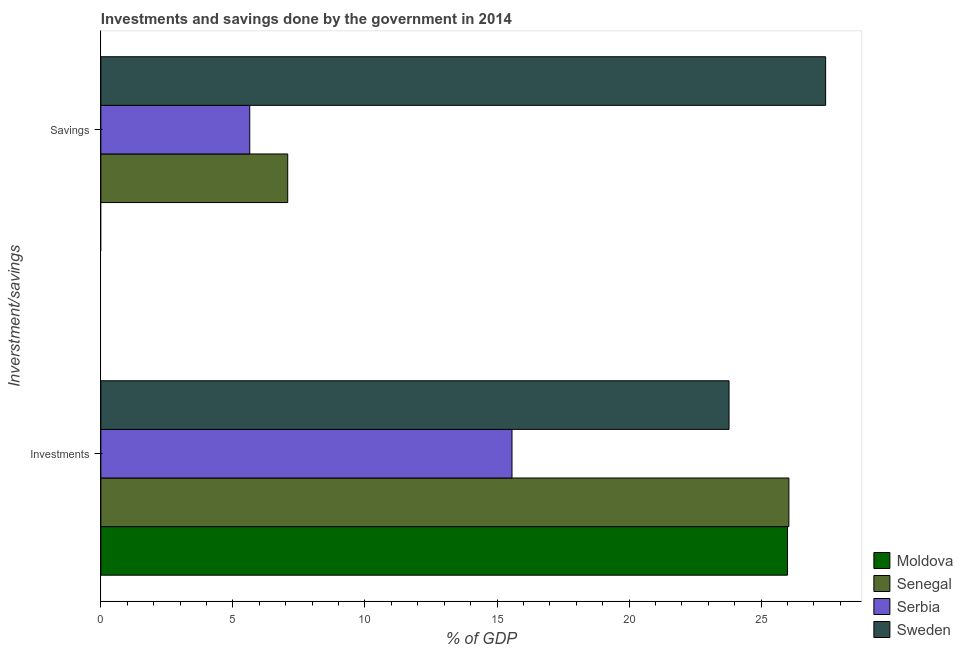How many different coloured bars are there?
Your answer should be very brief. 4. Are the number of bars on each tick of the Y-axis equal?
Keep it short and to the point. No. How many bars are there on the 1st tick from the bottom?
Give a very brief answer. 4. What is the label of the 1st group of bars from the top?
Your answer should be compact. Savings. What is the investments of government in Serbia?
Provide a short and direct response. 15.57. Across all countries, what is the maximum savings of government?
Your answer should be very brief. 27.44. Across all countries, what is the minimum investments of government?
Provide a succinct answer. 15.57. In which country was the savings of government maximum?
Provide a succinct answer. Sweden. What is the total investments of government in the graph?
Provide a short and direct response. 91.4. What is the difference between the investments of government in Serbia and that in Moldova?
Ensure brevity in your answer.  -10.43. What is the difference between the investments of government in Sweden and the savings of government in Senegal?
Your answer should be very brief. 16.71. What is the average investments of government per country?
Your response must be concise. 22.85. What is the difference between the investments of government and savings of government in Serbia?
Provide a succinct answer. 9.93. In how many countries, is the investments of government greater than 26 %?
Offer a terse response. 1. What is the ratio of the investments of government in Moldova to that in Serbia?
Provide a short and direct response. 1.67. Are all the bars in the graph horizontal?
Your response must be concise. Yes. How many countries are there in the graph?
Ensure brevity in your answer.  4. Are the values on the major ticks of X-axis written in scientific E-notation?
Provide a short and direct response. No. Where does the legend appear in the graph?
Provide a short and direct response. Bottom right. How are the legend labels stacked?
Make the answer very short. Vertical. What is the title of the graph?
Provide a succinct answer. Investments and savings done by the government in 2014. What is the label or title of the X-axis?
Offer a very short reply. % of GDP. What is the label or title of the Y-axis?
Your answer should be compact. Inverstment/savings. What is the % of GDP of Moldova in Investments?
Provide a short and direct response. 26. What is the % of GDP of Senegal in Investments?
Keep it short and to the point. 26.05. What is the % of GDP of Serbia in Investments?
Provide a succinct answer. 15.57. What is the % of GDP in Sweden in Investments?
Make the answer very short. 23.78. What is the % of GDP in Moldova in Savings?
Your answer should be compact. 0. What is the % of GDP of Senegal in Savings?
Keep it short and to the point. 7.08. What is the % of GDP in Serbia in Savings?
Ensure brevity in your answer.  5.64. What is the % of GDP of Sweden in Savings?
Provide a succinct answer. 27.44. Across all Inverstment/savings, what is the maximum % of GDP in Moldova?
Provide a succinct answer. 26. Across all Inverstment/savings, what is the maximum % of GDP in Senegal?
Keep it short and to the point. 26.05. Across all Inverstment/savings, what is the maximum % of GDP of Serbia?
Provide a succinct answer. 15.57. Across all Inverstment/savings, what is the maximum % of GDP in Sweden?
Provide a succinct answer. 27.44. Across all Inverstment/savings, what is the minimum % of GDP in Senegal?
Offer a very short reply. 7.08. Across all Inverstment/savings, what is the minimum % of GDP of Serbia?
Make the answer very short. 5.64. Across all Inverstment/savings, what is the minimum % of GDP of Sweden?
Your answer should be compact. 23.78. What is the total % of GDP of Moldova in the graph?
Keep it short and to the point. 26. What is the total % of GDP in Senegal in the graph?
Ensure brevity in your answer.  33.12. What is the total % of GDP of Serbia in the graph?
Provide a short and direct response. 21.2. What is the total % of GDP in Sweden in the graph?
Give a very brief answer. 51.23. What is the difference between the % of GDP of Senegal in Investments and that in Savings?
Keep it short and to the point. 18.97. What is the difference between the % of GDP of Serbia in Investments and that in Savings?
Your answer should be compact. 9.93. What is the difference between the % of GDP in Sweden in Investments and that in Savings?
Make the answer very short. -3.66. What is the difference between the % of GDP of Moldova in Investments and the % of GDP of Senegal in Savings?
Make the answer very short. 18.92. What is the difference between the % of GDP of Moldova in Investments and the % of GDP of Serbia in Savings?
Ensure brevity in your answer.  20.36. What is the difference between the % of GDP in Moldova in Investments and the % of GDP in Sweden in Savings?
Your response must be concise. -1.44. What is the difference between the % of GDP of Senegal in Investments and the % of GDP of Serbia in Savings?
Provide a short and direct response. 20.41. What is the difference between the % of GDP in Senegal in Investments and the % of GDP in Sweden in Savings?
Give a very brief answer. -1.39. What is the difference between the % of GDP of Serbia in Investments and the % of GDP of Sweden in Savings?
Your answer should be very brief. -11.87. What is the average % of GDP of Moldova per Inverstment/savings?
Keep it short and to the point. 13. What is the average % of GDP of Senegal per Inverstment/savings?
Offer a terse response. 16.56. What is the average % of GDP in Serbia per Inverstment/savings?
Keep it short and to the point. 10.6. What is the average % of GDP in Sweden per Inverstment/savings?
Provide a short and direct response. 25.61. What is the difference between the % of GDP in Moldova and % of GDP in Senegal in Investments?
Offer a very short reply. -0.05. What is the difference between the % of GDP of Moldova and % of GDP of Serbia in Investments?
Offer a very short reply. 10.43. What is the difference between the % of GDP in Moldova and % of GDP in Sweden in Investments?
Ensure brevity in your answer.  2.21. What is the difference between the % of GDP in Senegal and % of GDP in Serbia in Investments?
Keep it short and to the point. 10.48. What is the difference between the % of GDP in Senegal and % of GDP in Sweden in Investments?
Offer a terse response. 2.27. What is the difference between the % of GDP of Serbia and % of GDP of Sweden in Investments?
Keep it short and to the point. -8.22. What is the difference between the % of GDP in Senegal and % of GDP in Serbia in Savings?
Offer a very short reply. 1.44. What is the difference between the % of GDP of Senegal and % of GDP of Sweden in Savings?
Make the answer very short. -20.37. What is the difference between the % of GDP in Serbia and % of GDP in Sweden in Savings?
Make the answer very short. -21.8. What is the ratio of the % of GDP of Senegal in Investments to that in Savings?
Your response must be concise. 3.68. What is the ratio of the % of GDP of Serbia in Investments to that in Savings?
Give a very brief answer. 2.76. What is the ratio of the % of GDP of Sweden in Investments to that in Savings?
Make the answer very short. 0.87. What is the difference between the highest and the second highest % of GDP in Senegal?
Your response must be concise. 18.97. What is the difference between the highest and the second highest % of GDP in Serbia?
Make the answer very short. 9.93. What is the difference between the highest and the second highest % of GDP of Sweden?
Offer a very short reply. 3.66. What is the difference between the highest and the lowest % of GDP of Moldova?
Keep it short and to the point. 26. What is the difference between the highest and the lowest % of GDP of Senegal?
Your answer should be compact. 18.97. What is the difference between the highest and the lowest % of GDP of Serbia?
Your answer should be compact. 9.93. What is the difference between the highest and the lowest % of GDP of Sweden?
Keep it short and to the point. 3.66. 